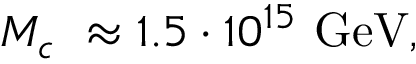Convert formula to latex. <formula><loc_0><loc_0><loc_500><loc_500>M _ { c } \approx 1 . 5 \cdot 1 0 ^ { 1 5 } G e V ,</formula> 